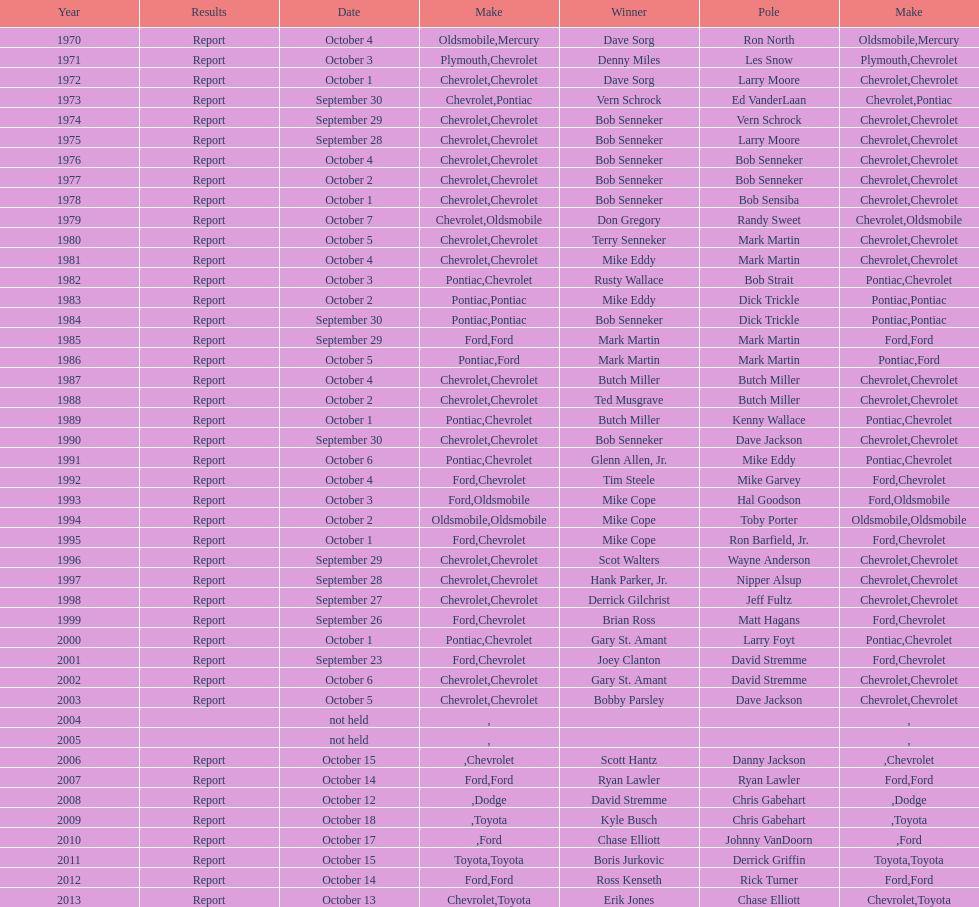Give me the full table as a dictionary. {'header': ['Year', 'Results', 'Date', 'Make', 'Winner', 'Pole', 'Make'], 'rows': [['1970', 'Report', 'October 4', 'Oldsmobile', 'Dave Sorg', 'Ron North', 'Mercury'], ['1971', 'Report', 'October 3', 'Plymouth', 'Denny Miles', 'Les Snow', 'Chevrolet'], ['1972', 'Report', 'October 1', 'Chevrolet', 'Dave Sorg', 'Larry Moore', 'Chevrolet'], ['1973', 'Report', 'September 30', 'Chevrolet', 'Vern Schrock', 'Ed VanderLaan', 'Pontiac'], ['1974', 'Report', 'September 29', 'Chevrolet', 'Bob Senneker', 'Vern Schrock', 'Chevrolet'], ['1975', 'Report', 'September 28', 'Chevrolet', 'Bob Senneker', 'Larry Moore', 'Chevrolet'], ['1976', 'Report', 'October 4', 'Chevrolet', 'Bob Senneker', 'Bob Senneker', 'Chevrolet'], ['1977', 'Report', 'October 2', 'Chevrolet', 'Bob Senneker', 'Bob Senneker', 'Chevrolet'], ['1978', 'Report', 'October 1', 'Chevrolet', 'Bob Senneker', 'Bob Sensiba', 'Chevrolet'], ['1979', 'Report', 'October 7', 'Chevrolet', 'Don Gregory', 'Randy Sweet', 'Oldsmobile'], ['1980', 'Report', 'October 5', 'Chevrolet', 'Terry Senneker', 'Mark Martin', 'Chevrolet'], ['1981', 'Report', 'October 4', 'Chevrolet', 'Mike Eddy', 'Mark Martin', 'Chevrolet'], ['1982', 'Report', 'October 3', 'Pontiac', 'Rusty Wallace', 'Bob Strait', 'Chevrolet'], ['1983', 'Report', 'October 2', 'Pontiac', 'Mike Eddy', 'Dick Trickle', 'Pontiac'], ['1984', 'Report', 'September 30', 'Pontiac', 'Bob Senneker', 'Dick Trickle', 'Pontiac'], ['1985', 'Report', 'September 29', 'Ford', 'Mark Martin', 'Mark Martin', 'Ford'], ['1986', 'Report', 'October 5', 'Pontiac', 'Mark Martin', 'Mark Martin', 'Ford'], ['1987', 'Report', 'October 4', 'Chevrolet', 'Butch Miller', 'Butch Miller', 'Chevrolet'], ['1988', 'Report', 'October 2', 'Chevrolet', 'Ted Musgrave', 'Butch Miller', 'Chevrolet'], ['1989', 'Report', 'October 1', 'Pontiac', 'Butch Miller', 'Kenny Wallace', 'Chevrolet'], ['1990', 'Report', 'September 30', 'Chevrolet', 'Bob Senneker', 'Dave Jackson', 'Chevrolet'], ['1991', 'Report', 'October 6', 'Pontiac', 'Glenn Allen, Jr.', 'Mike Eddy', 'Chevrolet'], ['1992', 'Report', 'October 4', 'Ford', 'Tim Steele', 'Mike Garvey', 'Chevrolet'], ['1993', 'Report', 'October 3', 'Ford', 'Mike Cope', 'Hal Goodson', 'Oldsmobile'], ['1994', 'Report', 'October 2', 'Oldsmobile', 'Mike Cope', 'Toby Porter', 'Oldsmobile'], ['1995', 'Report', 'October 1', 'Ford', 'Mike Cope', 'Ron Barfield, Jr.', 'Chevrolet'], ['1996', 'Report', 'September 29', 'Chevrolet', 'Scot Walters', 'Wayne Anderson', 'Chevrolet'], ['1997', 'Report', 'September 28', 'Chevrolet', 'Hank Parker, Jr.', 'Nipper Alsup', 'Chevrolet'], ['1998', 'Report', 'September 27', 'Chevrolet', 'Derrick Gilchrist', 'Jeff Fultz', 'Chevrolet'], ['1999', 'Report', 'September 26', 'Ford', 'Brian Ross', 'Matt Hagans', 'Chevrolet'], ['2000', 'Report', 'October 1', 'Pontiac', 'Gary St. Amant', 'Larry Foyt', 'Chevrolet'], ['2001', 'Report', 'September 23', 'Ford', 'Joey Clanton', 'David Stremme', 'Chevrolet'], ['2002', 'Report', 'October 6', 'Chevrolet', 'Gary St. Amant', 'David Stremme', 'Chevrolet'], ['2003', 'Report', 'October 5', 'Chevrolet', 'Bobby Parsley', 'Dave Jackson', 'Chevrolet'], ['2004', '', 'not held', '', '', '', ''], ['2005', '', 'not held', '', '', '', ''], ['2006', 'Report', 'October 15', '', 'Scott Hantz', 'Danny Jackson', 'Chevrolet'], ['2007', 'Report', 'October 14', 'Ford', 'Ryan Lawler', 'Ryan Lawler', 'Ford'], ['2008', 'Report', 'October 12', '', 'David Stremme', 'Chris Gabehart', 'Dodge'], ['2009', 'Report', 'October 18', '', 'Kyle Busch', 'Chris Gabehart', 'Toyota'], ['2010', 'Report', 'October 17', '', 'Chase Elliott', 'Johnny VanDoorn', 'Ford'], ['2011', 'Report', 'October 15', 'Toyota', 'Boris Jurkovic', 'Derrick Griffin', 'Toyota'], ['2012', 'Report', 'October 14', 'Ford', 'Ross Kenseth', 'Rick Turner', 'Ford'], ['2013', 'Report', 'October 13', 'Chevrolet', 'Erik Jones', 'Chase Elliott', 'Toyota']]} Which month held the most winchester 400 races? October. 